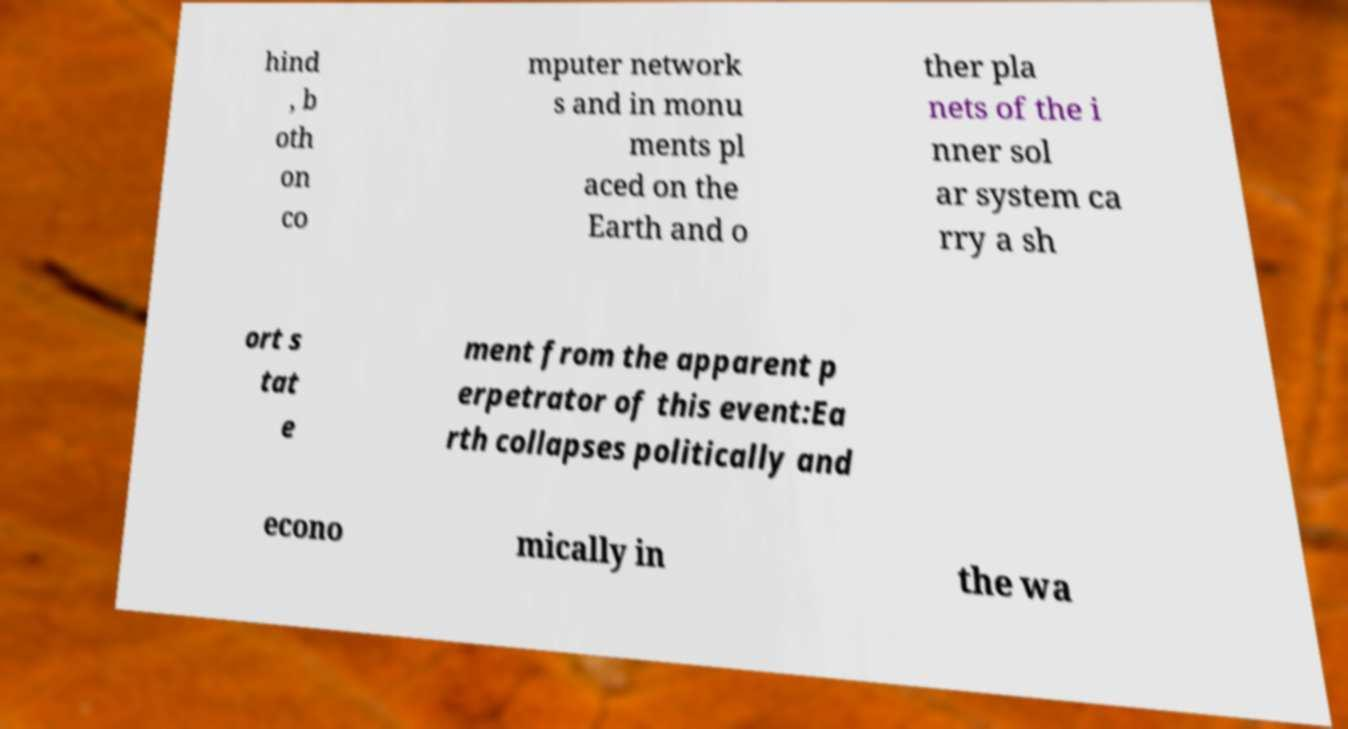There's text embedded in this image that I need extracted. Can you transcribe it verbatim? hind , b oth on co mputer network s and in monu ments pl aced on the Earth and o ther pla nets of the i nner sol ar system ca rry a sh ort s tat e ment from the apparent p erpetrator of this event:Ea rth collapses politically and econo mically in the wa 